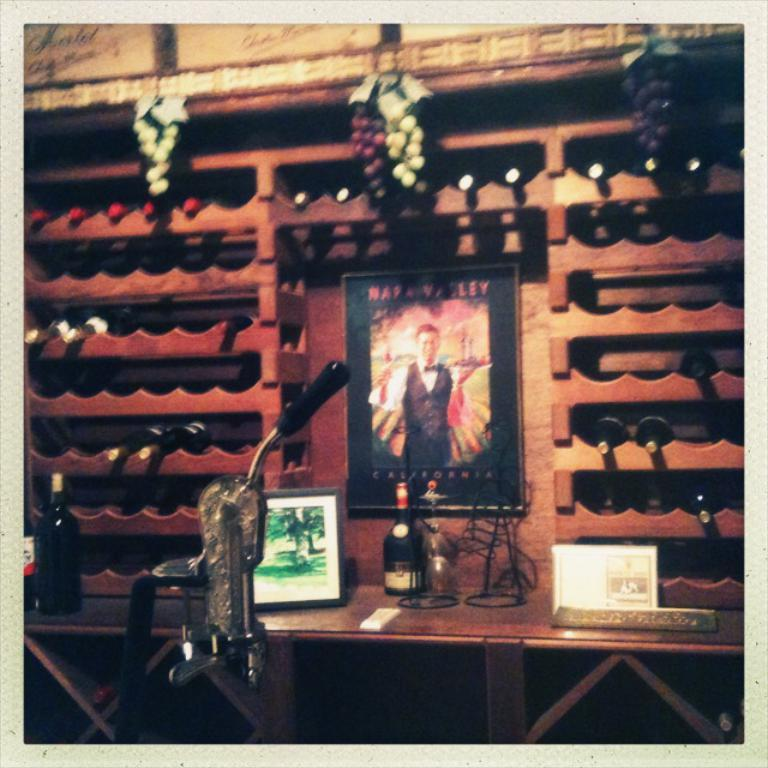<image>
Give a short and clear explanation of the subsequent image. In a wine storage room, a framed picture depicts a waiter and the location of Napa Valley, California is written on it. 